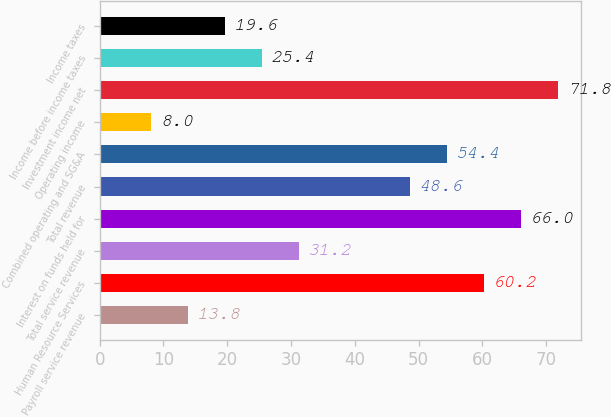<chart> <loc_0><loc_0><loc_500><loc_500><bar_chart><fcel>Payroll service revenue<fcel>Human Resource Services<fcel>Total service revenue<fcel>Interest on funds held for<fcel>Total revenue<fcel>Combined operating and SG&A<fcel>Operating income<fcel>Investment income net<fcel>Income before income taxes<fcel>Income taxes<nl><fcel>13.8<fcel>60.2<fcel>31.2<fcel>66<fcel>48.6<fcel>54.4<fcel>8<fcel>71.8<fcel>25.4<fcel>19.6<nl></chart> 